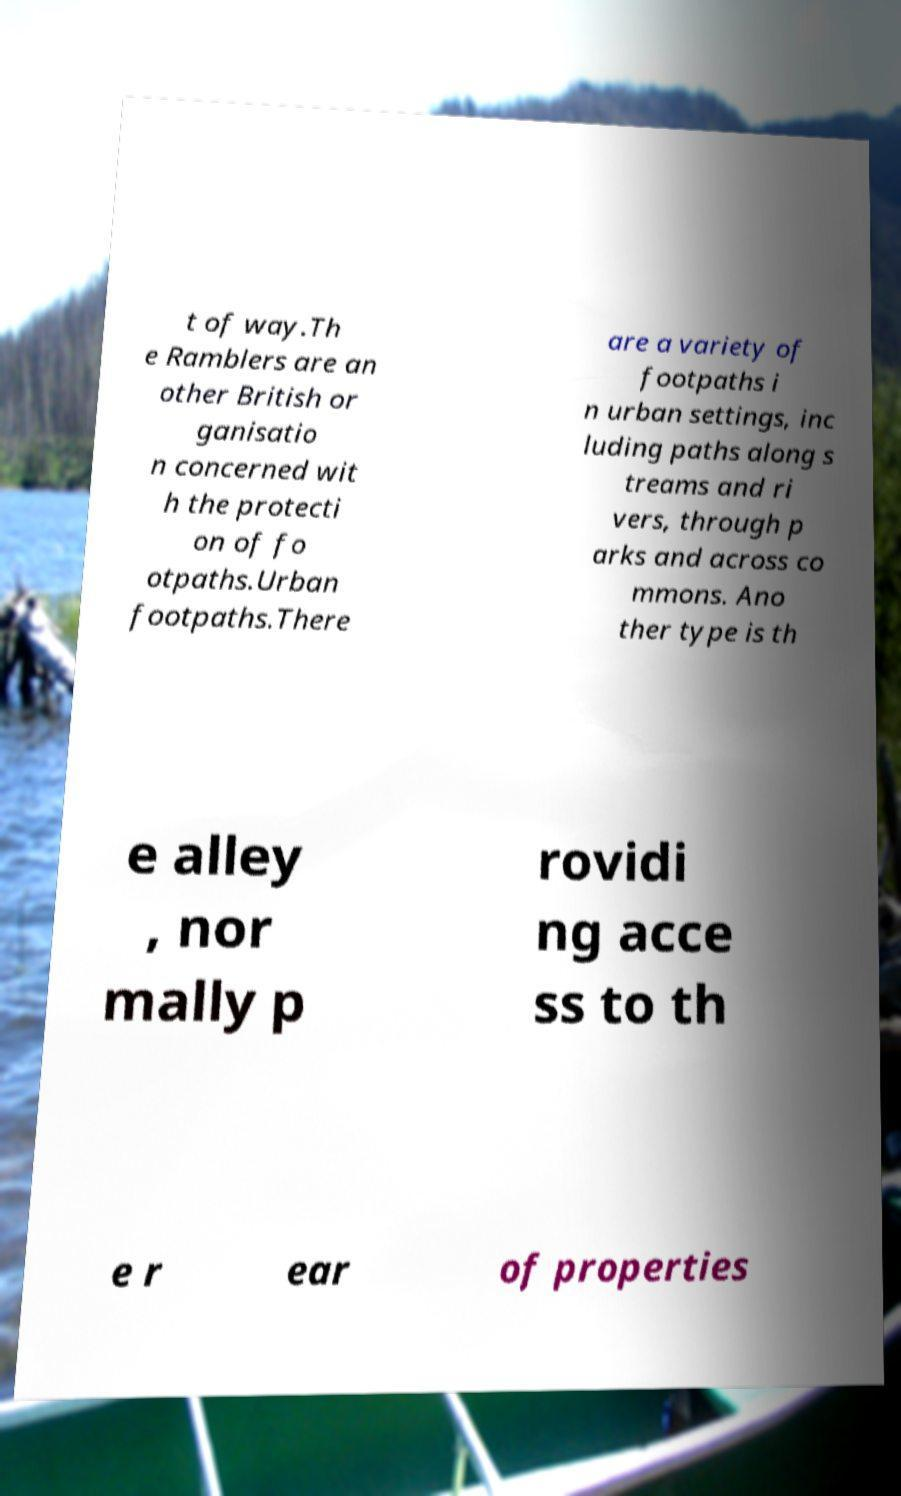Please read and relay the text visible in this image. What does it say? t of way.Th e Ramblers are an other British or ganisatio n concerned wit h the protecti on of fo otpaths.Urban footpaths.There are a variety of footpaths i n urban settings, inc luding paths along s treams and ri vers, through p arks and across co mmons. Ano ther type is th e alley , nor mally p rovidi ng acce ss to th e r ear of properties 